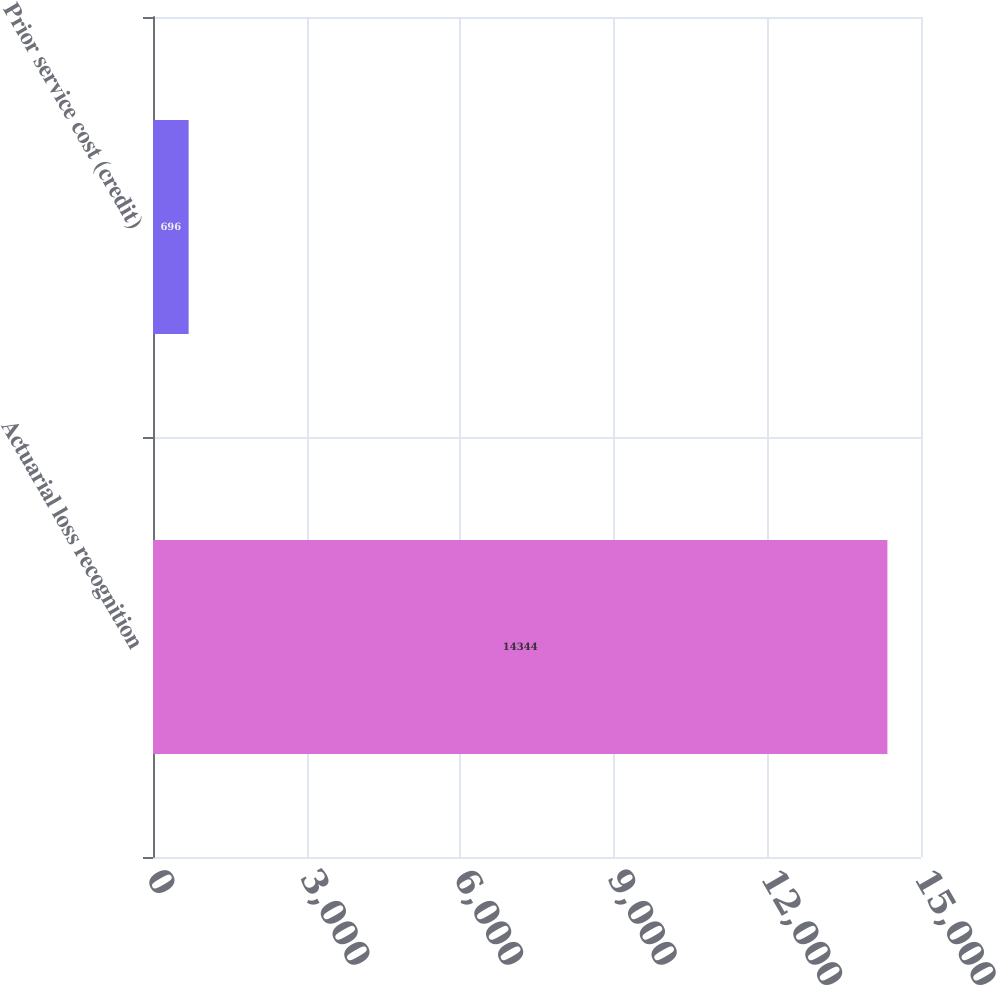Convert chart to OTSL. <chart><loc_0><loc_0><loc_500><loc_500><bar_chart><fcel>Actuarial loss recognition<fcel>Prior service cost (credit)<nl><fcel>14344<fcel>696<nl></chart> 